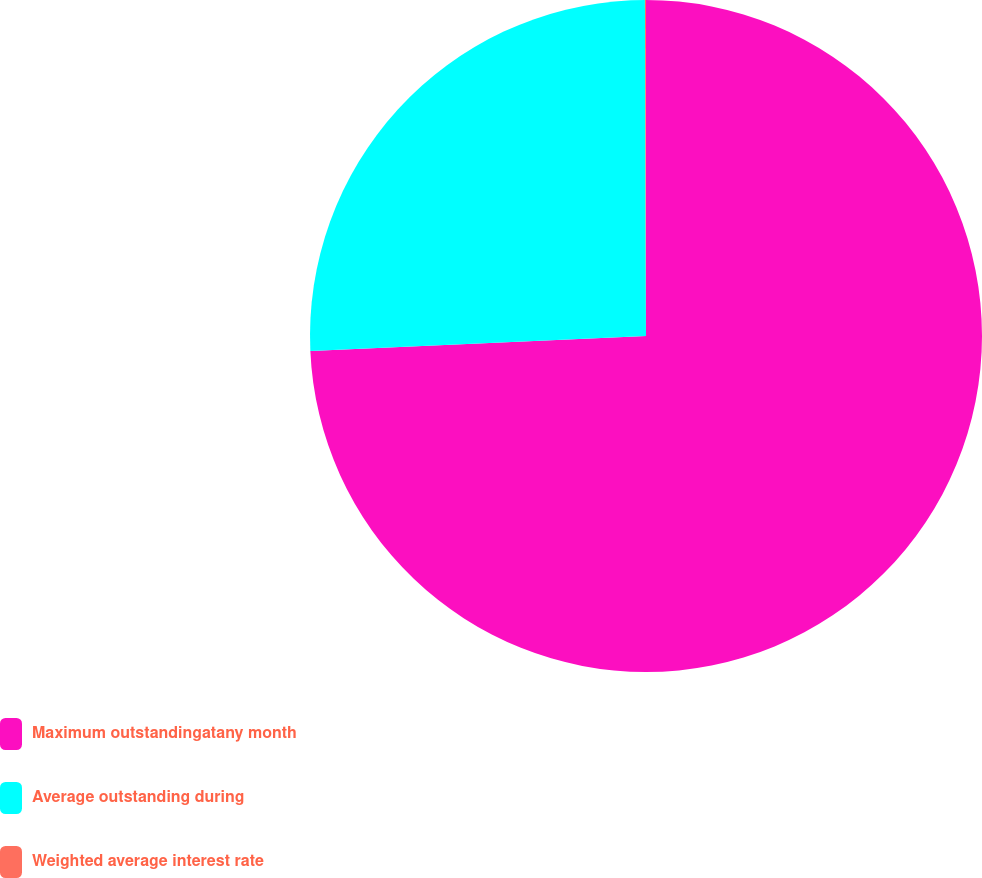<chart> <loc_0><loc_0><loc_500><loc_500><pie_chart><fcel>Maximum outstandingatany month<fcel>Average outstanding during<fcel>Weighted average interest rate<nl><fcel>74.29%<fcel>25.66%<fcel>0.05%<nl></chart> 